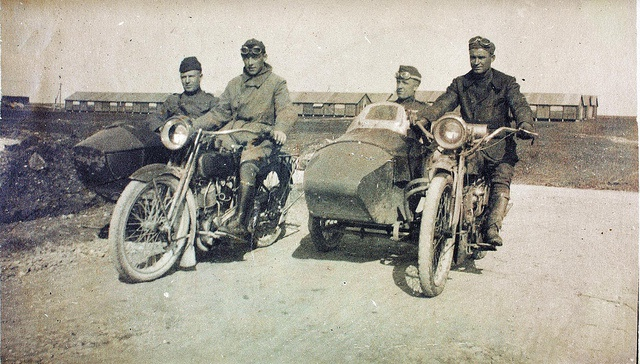Describe the objects in this image and their specific colors. I can see motorcycle in darkgray, gray, black, and lightgray tones, motorcycle in darkgray, black, gray, and lightgray tones, people in darkgray, gray, and black tones, people in darkgray, gray, and black tones, and people in darkgray, gray, and black tones in this image. 